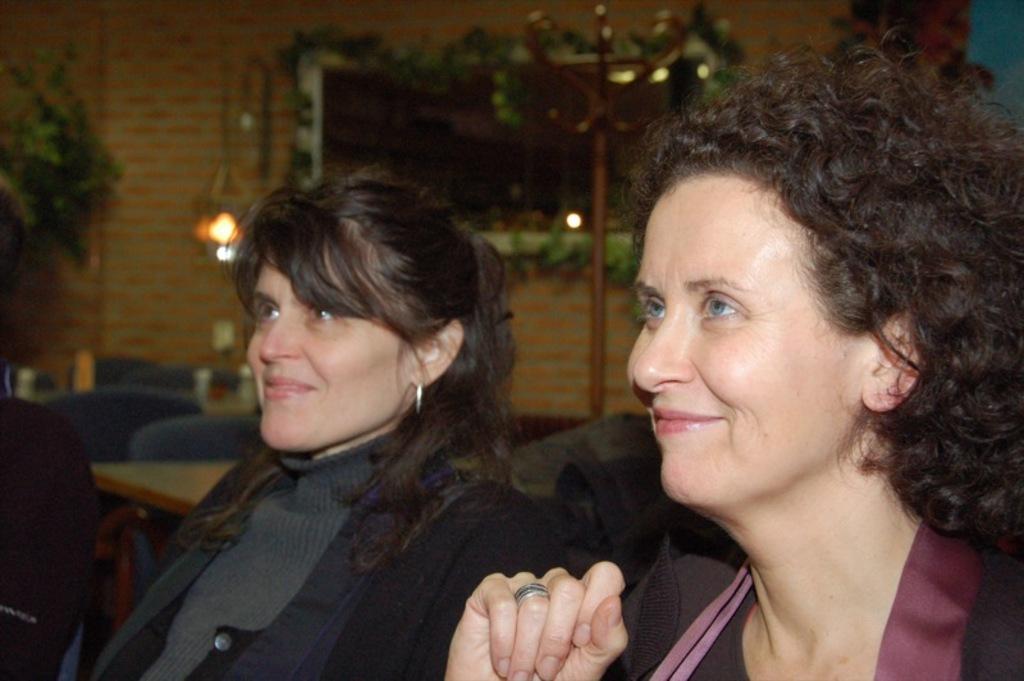In one or two sentences, can you explain what this image depicts? In the image there are two women, they are looking at something and smiling and they are sitting in a restaurant and behind the women there is a wall and there is a light hanged to the wall and there are some plants arranged in front of the wall. 